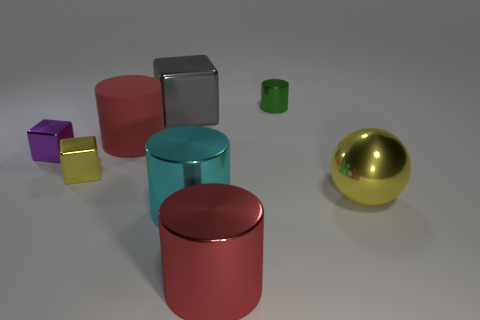Subtract 1 cylinders. How many cylinders are left? 3 Add 1 green shiny objects. How many objects exist? 9 Subtract all spheres. How many objects are left? 7 Subtract all large red metal cylinders. Subtract all big yellow objects. How many objects are left? 6 Add 2 red metallic cylinders. How many red metallic cylinders are left? 3 Add 3 tiny brown metallic balls. How many tiny brown metallic balls exist? 3 Subtract 0 cyan spheres. How many objects are left? 8 